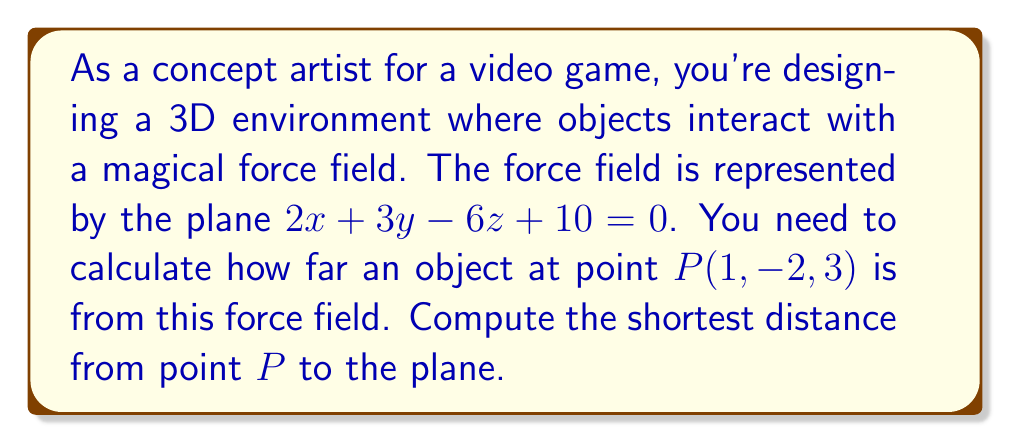Provide a solution to this math problem. Let's approach this step-by-step:

1) The general equation for the distance $d$ from a point $(x_0, y_0, z_0)$ to a plane $Ax + By + Cz + D = 0$ is:

   $$d = \frac{|Ax_0 + By_0 + Cz_0 + D|}{\sqrt{A^2 + B^2 + C^2}}$$

2) In our case:
   - The plane equation is $2x + 3y - 6z + 10 = 0$, so $A=2$, $B=3$, $C=-6$, and $D=10$
   - The point $P$ is at $(1, -2, 3)$, so $x_0=1$, $y_0=-2$, and $z_0=3$

3) Let's substitute these values into our distance formula:

   $$d = \frac{|2(1) + 3(-2) - 6(3) + 10|}{\sqrt{2^2 + 3^2 + (-6)^2}}$$

4) Simplify the numerator:
   $$d = \frac{|2 - 6 - 18 + 10|}{\sqrt{4 + 9 + 36}}$$
   $$d = \frac{|-12|}{\sqrt{49}}$$

5) Simplify further:
   $$d = \frac{12}{7}$$

This fraction can be left as is or converted to a decimal if needed.
Answer: $\frac{12}{7}$ units 